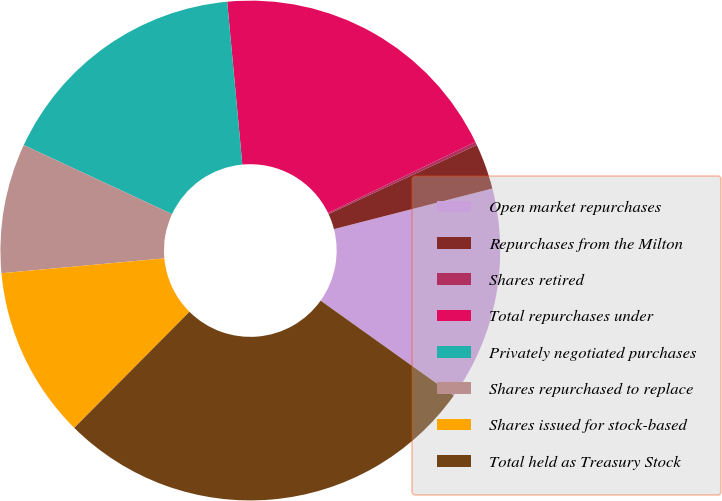Convert chart to OTSL. <chart><loc_0><loc_0><loc_500><loc_500><pie_chart><fcel>Open market repurchases<fcel>Repurchases from the Milton<fcel>Shares retired<fcel>Total repurchases under<fcel>Privately negotiated purchases<fcel>Shares repurchased to replace<fcel>Shares issued for stock-based<fcel>Total held as Treasury Stock<nl><fcel>13.85%<fcel>2.95%<fcel>0.21%<fcel>19.32%<fcel>16.59%<fcel>8.38%<fcel>11.11%<fcel>27.58%<nl></chart> 